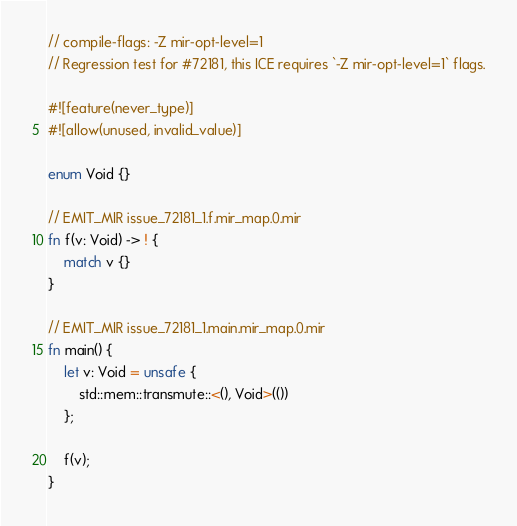<code> <loc_0><loc_0><loc_500><loc_500><_Rust_>// compile-flags: -Z mir-opt-level=1
// Regression test for #72181, this ICE requires `-Z mir-opt-level=1` flags.

#![feature(never_type)]
#![allow(unused, invalid_value)]

enum Void {}

// EMIT_MIR issue_72181_1.f.mir_map.0.mir
fn f(v: Void) -> ! {
    match v {}
}

// EMIT_MIR issue_72181_1.main.mir_map.0.mir
fn main() {
    let v: Void = unsafe {
        std::mem::transmute::<(), Void>(())
    };

    f(v);
}
</code> 